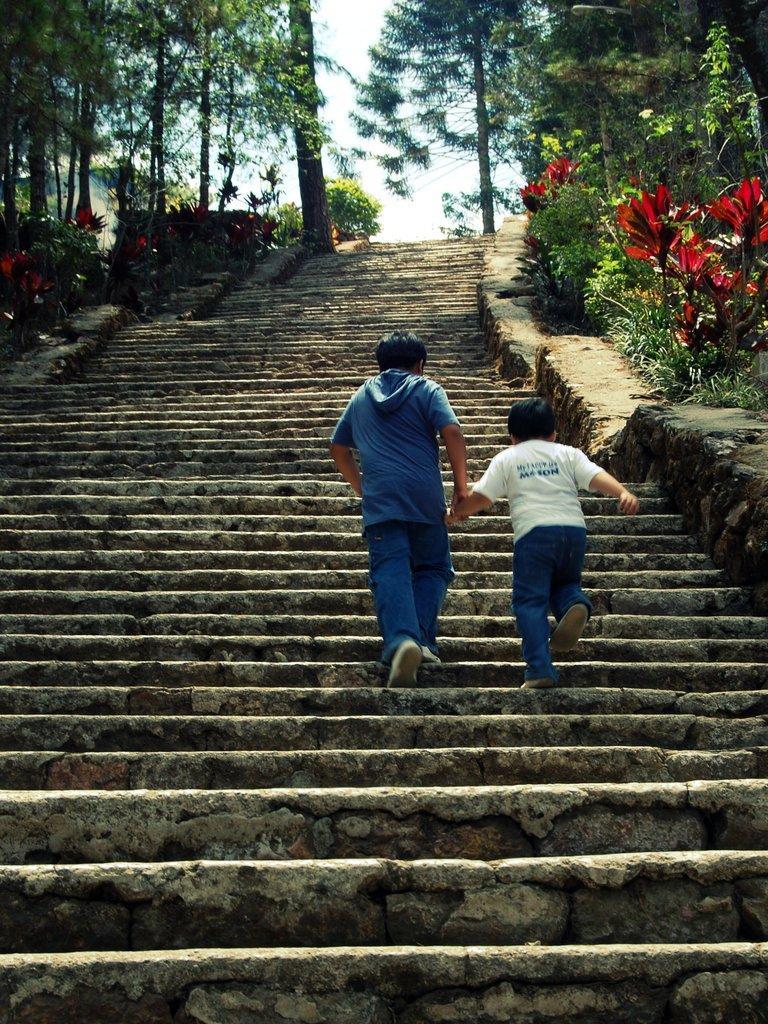In one or two sentences, can you explain what this image depicts? In this image there are persons climbing stairs and there are trees. 